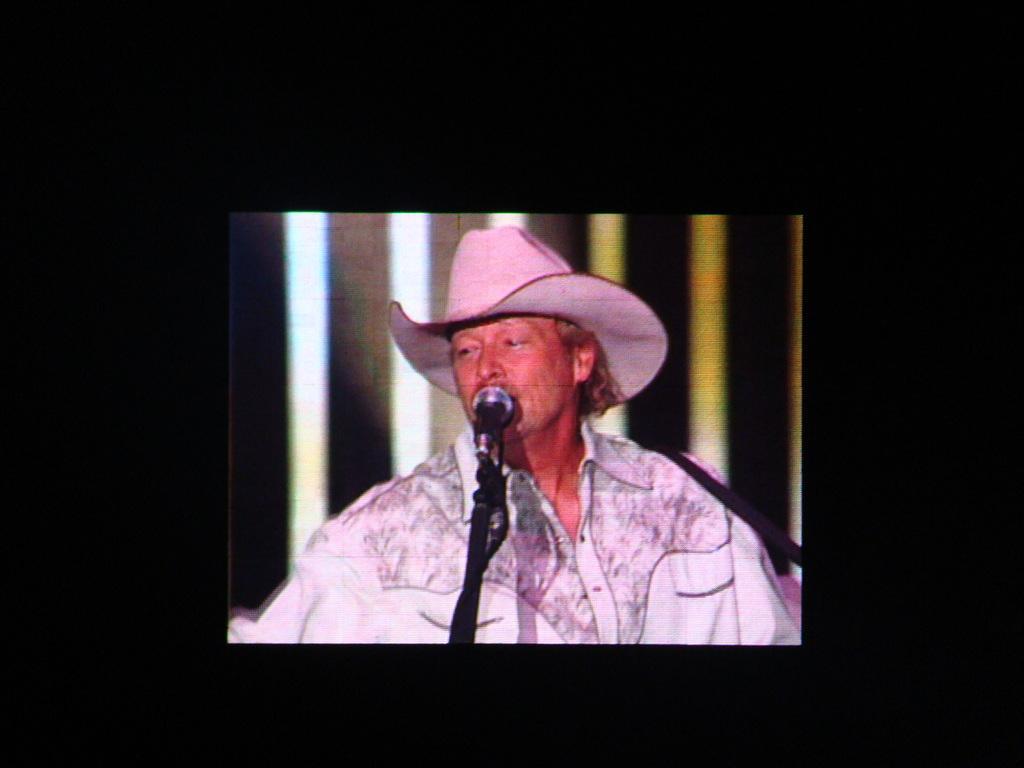Describe this image in one or two sentences. In the picture we can see a screen with a man singing a song into the microphone and he is wearing a white color shirt and a hat which is also white in color and some pink color light focus on him. 